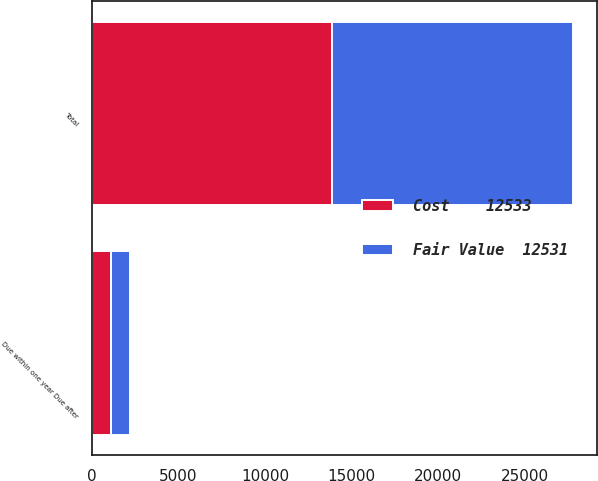Convert chart. <chart><loc_0><loc_0><loc_500><loc_500><stacked_bar_chart><ecel><fcel>Due within one year Due after<fcel>Total<nl><fcel>Fair Value  12531<fcel>1086<fcel>13884<nl><fcel>Cost    12533<fcel>1084<fcel>13877<nl></chart> 